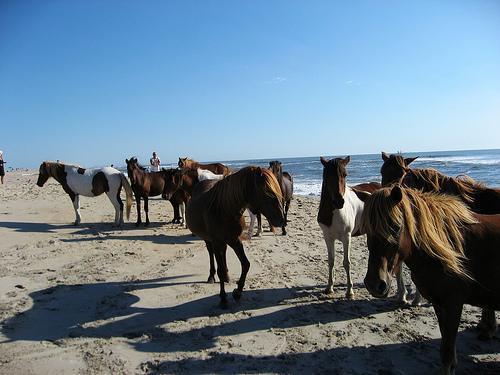How many horses are there?
Give a very brief answer. 10. How many people?
Give a very brief answer. 1. How many horses are pictured?
Give a very brief answer. 9. How many people are pictured?
Give a very brief answer. 2. 